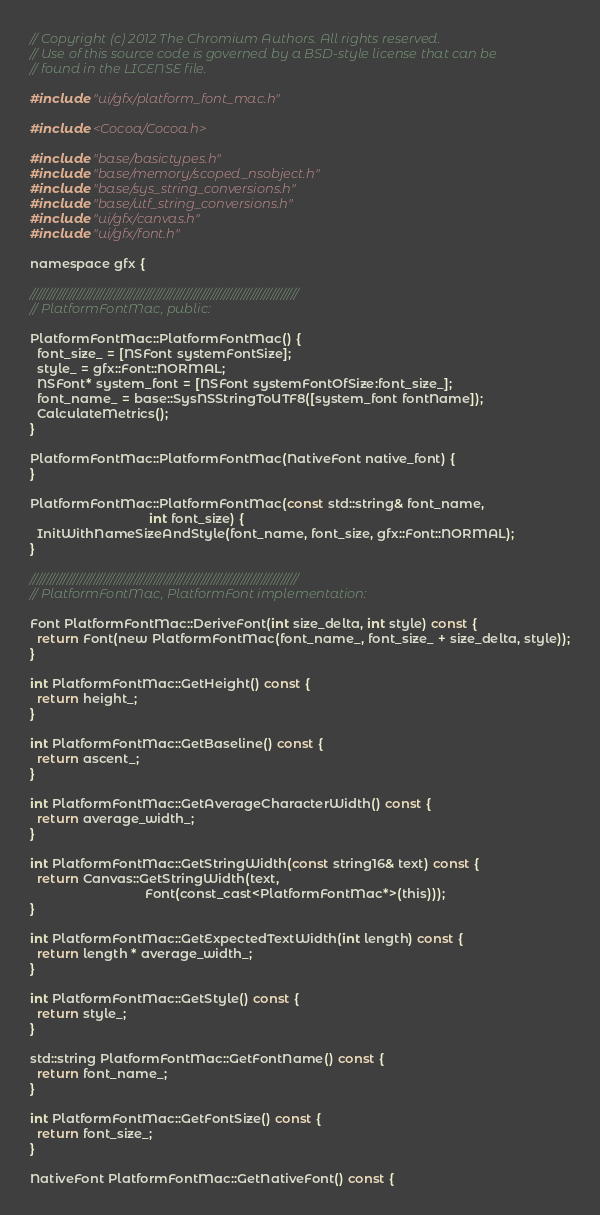Convert code to text. <code><loc_0><loc_0><loc_500><loc_500><_ObjectiveC_>// Copyright (c) 2012 The Chromium Authors. All rights reserved.
// Use of this source code is governed by a BSD-style license that can be
// found in the LICENSE file.

#include "ui/gfx/platform_font_mac.h"

#include <Cocoa/Cocoa.h>

#include "base/basictypes.h"
#include "base/memory/scoped_nsobject.h"
#include "base/sys_string_conversions.h"
#include "base/utf_string_conversions.h"
#include "ui/gfx/canvas.h"
#include "ui/gfx/font.h"

namespace gfx {

////////////////////////////////////////////////////////////////////////////////
// PlatformFontMac, public:

PlatformFontMac::PlatformFontMac() {
  font_size_ = [NSFont systemFontSize];
  style_ = gfx::Font::NORMAL;
  NSFont* system_font = [NSFont systemFontOfSize:font_size_];
  font_name_ = base::SysNSStringToUTF8([system_font fontName]);
  CalculateMetrics();
}

PlatformFontMac::PlatformFontMac(NativeFont native_font) {
}

PlatformFontMac::PlatformFontMac(const std::string& font_name,
                                 int font_size) {
  InitWithNameSizeAndStyle(font_name, font_size, gfx::Font::NORMAL);
}

////////////////////////////////////////////////////////////////////////////////
// PlatformFontMac, PlatformFont implementation:

Font PlatformFontMac::DeriveFont(int size_delta, int style) const {
  return Font(new PlatformFontMac(font_name_, font_size_ + size_delta, style));
}

int PlatformFontMac::GetHeight() const {
  return height_;
}

int PlatformFontMac::GetBaseline() const {
  return ascent_;
}

int PlatformFontMac::GetAverageCharacterWidth() const {
  return average_width_;
}

int PlatformFontMac::GetStringWidth(const string16& text) const {
  return Canvas::GetStringWidth(text,
                                Font(const_cast<PlatformFontMac*>(this)));
}

int PlatformFontMac::GetExpectedTextWidth(int length) const {
  return length * average_width_;
}

int PlatformFontMac::GetStyle() const {
  return style_;
}

std::string PlatformFontMac::GetFontName() const {
  return font_name_;
}

int PlatformFontMac::GetFontSize() const {
  return font_size_;
}

NativeFont PlatformFontMac::GetNativeFont() const {</code> 